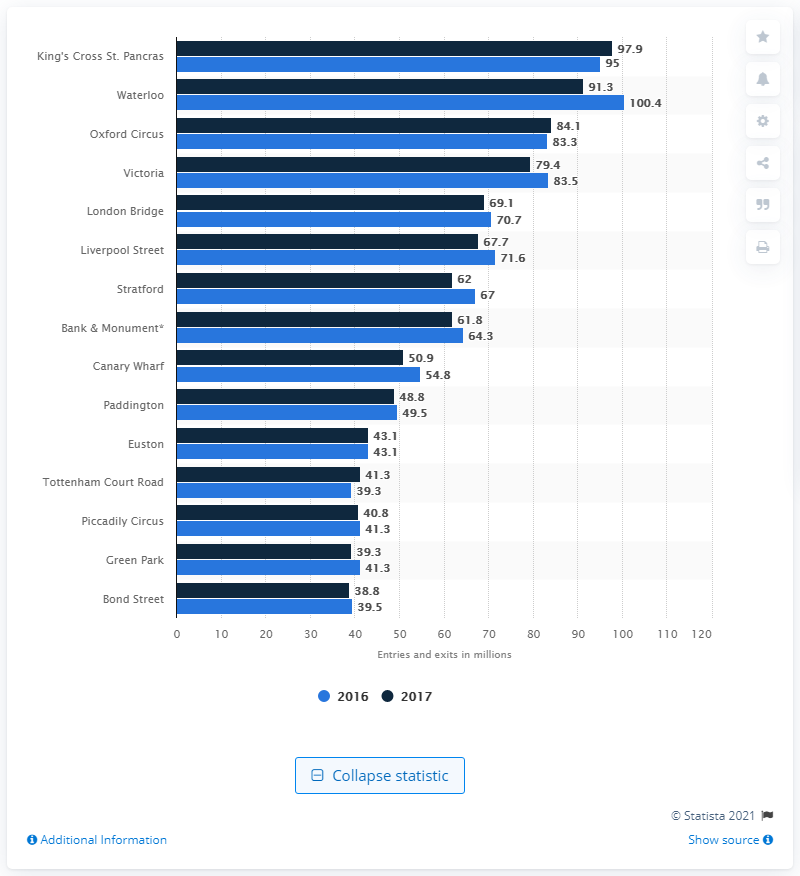Give some essential details in this illustration. In the year before the construction of Waterloo station, 100.4 passenger entries and exits were recorded. According to data from 2017, King's Cross St. Pancras was the busiest tube station in London. 